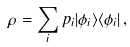Convert formula to latex. <formula><loc_0><loc_0><loc_500><loc_500>\rho = \sum _ { i } p _ { i } | \phi _ { i } \rangle \langle \phi _ { i } | \, ,</formula> 